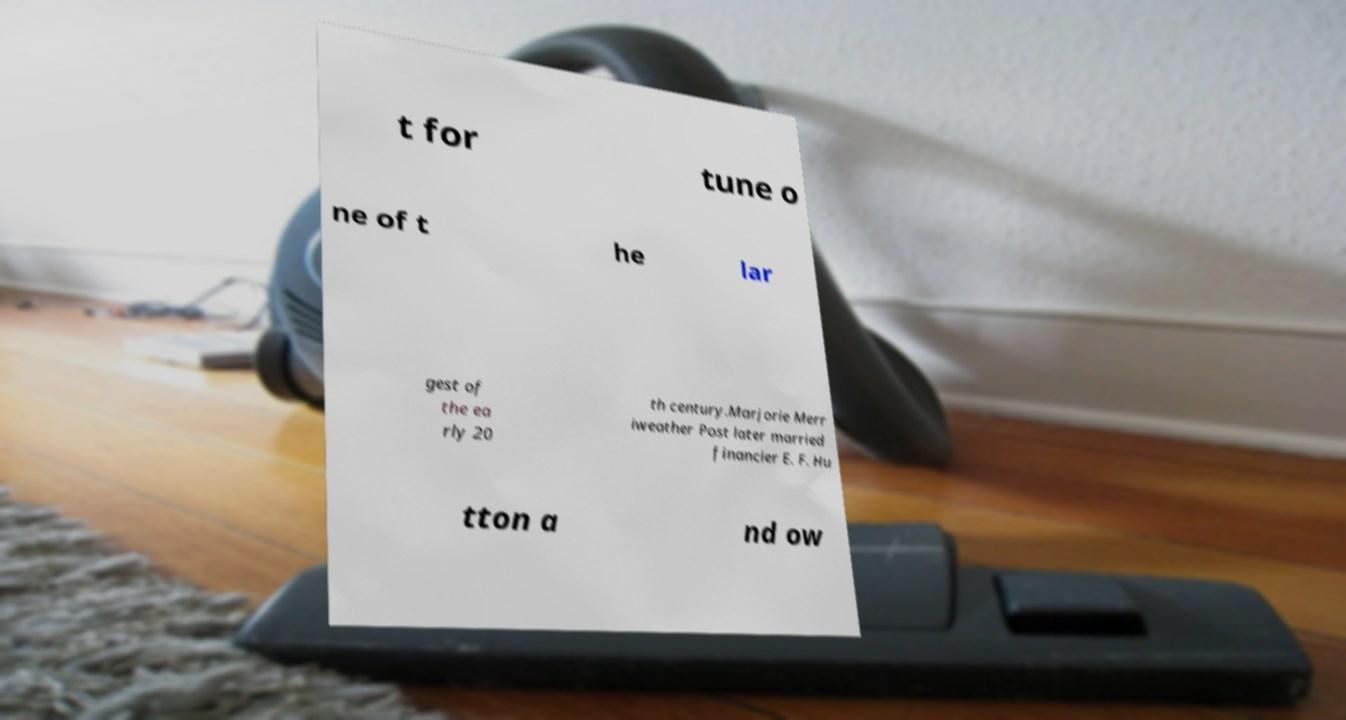I need the written content from this picture converted into text. Can you do that? t for tune o ne of t he lar gest of the ea rly 20 th century.Marjorie Merr iweather Post later married financier E. F. Hu tton a nd ow 